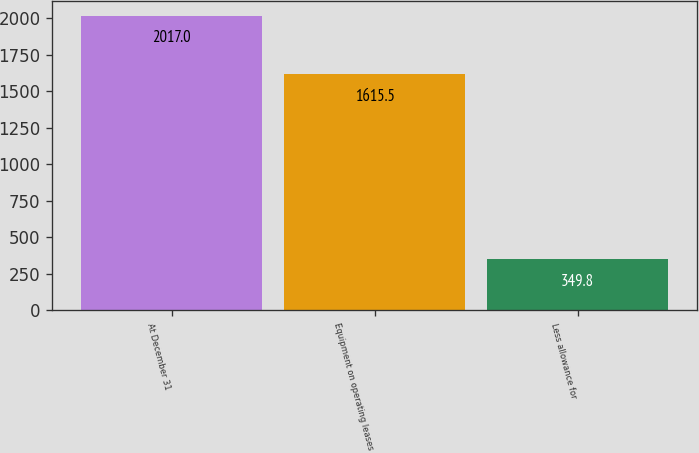Convert chart to OTSL. <chart><loc_0><loc_0><loc_500><loc_500><bar_chart><fcel>At December 31<fcel>Equipment on operating leases<fcel>Less allowance for<nl><fcel>2017<fcel>1615.5<fcel>349.8<nl></chart> 